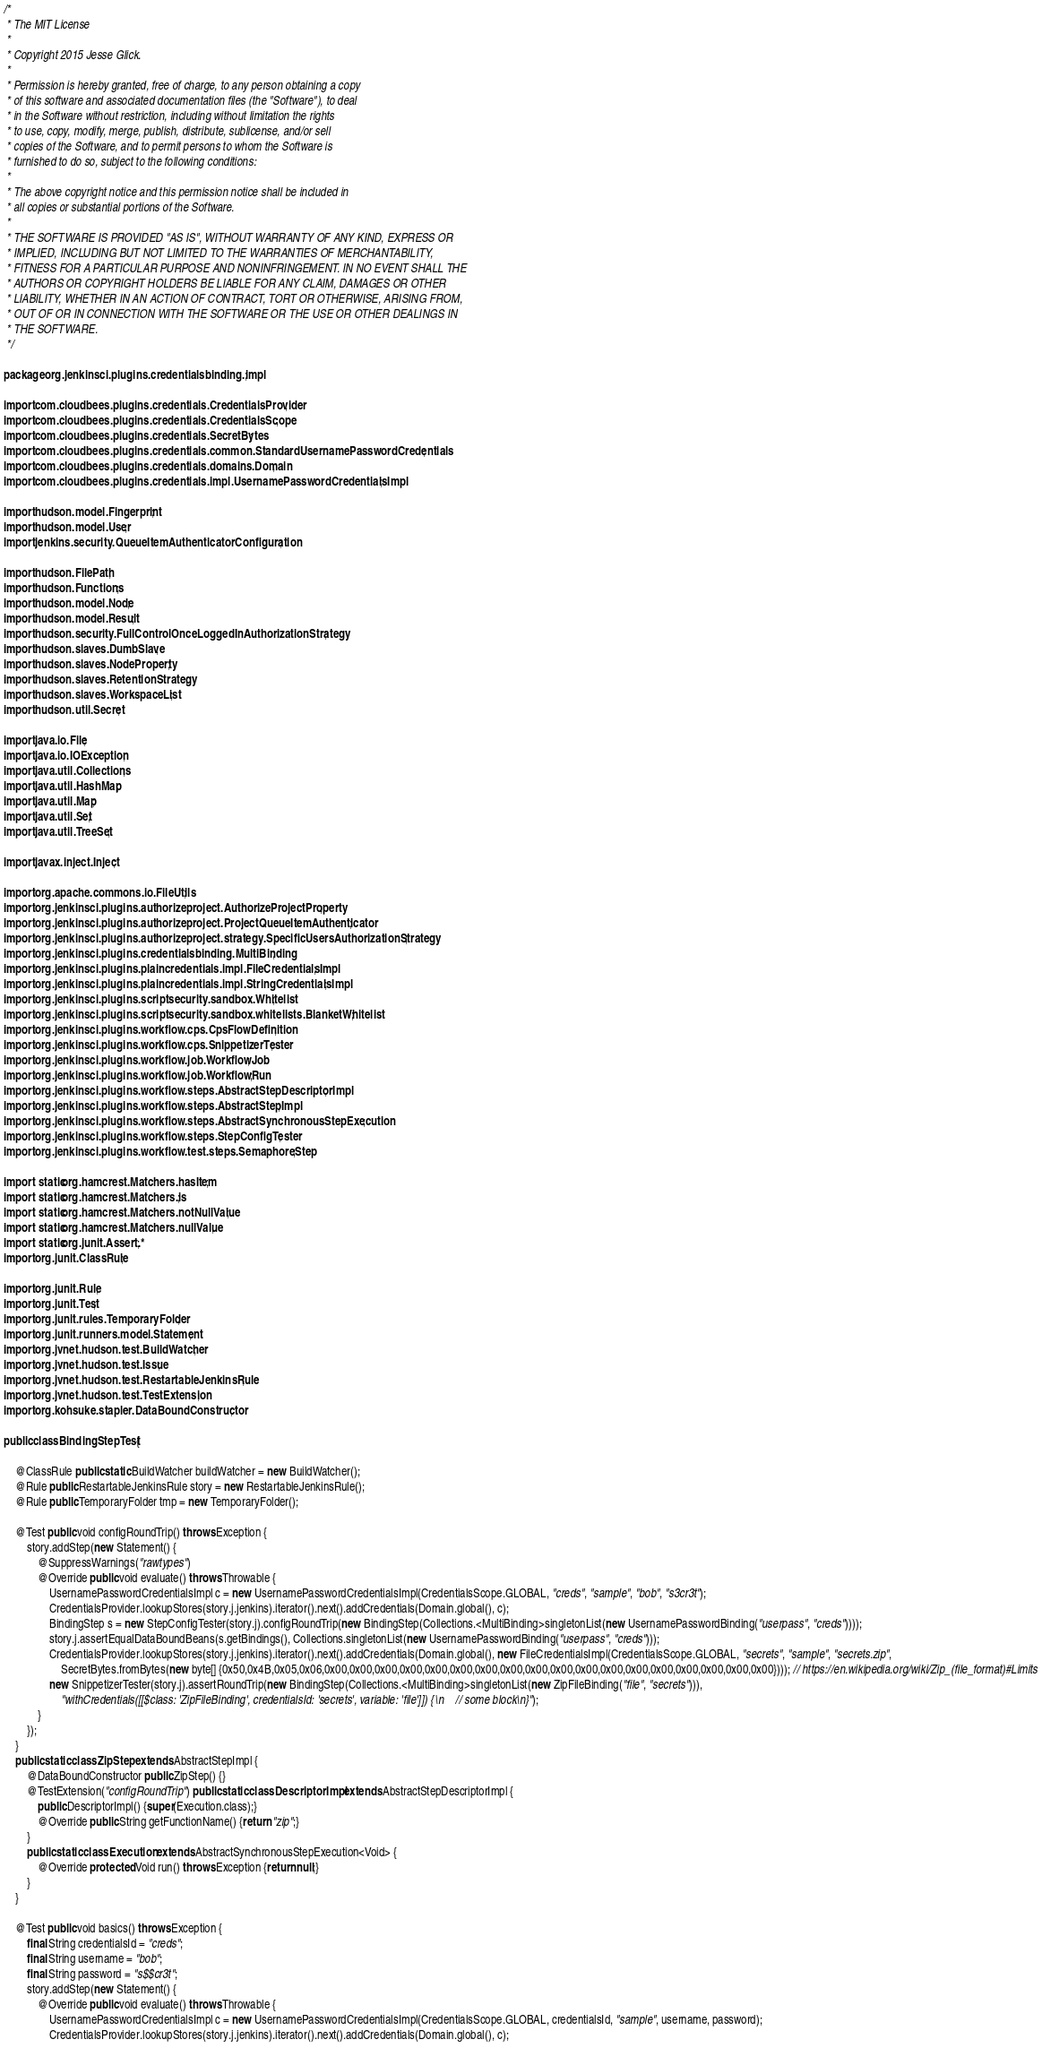Convert code to text. <code><loc_0><loc_0><loc_500><loc_500><_Java_>/*
 * The MIT License
 *
 * Copyright 2015 Jesse Glick.
 *
 * Permission is hereby granted, free of charge, to any person obtaining a copy
 * of this software and associated documentation files (the "Software"), to deal
 * in the Software without restriction, including without limitation the rights
 * to use, copy, modify, merge, publish, distribute, sublicense, and/or sell
 * copies of the Software, and to permit persons to whom the Software is
 * furnished to do so, subject to the following conditions:
 *
 * The above copyright notice and this permission notice shall be included in
 * all copies or substantial portions of the Software.
 *
 * THE SOFTWARE IS PROVIDED "AS IS", WITHOUT WARRANTY OF ANY KIND, EXPRESS OR
 * IMPLIED, INCLUDING BUT NOT LIMITED TO THE WARRANTIES OF MERCHANTABILITY,
 * FITNESS FOR A PARTICULAR PURPOSE AND NONINFRINGEMENT. IN NO EVENT SHALL THE
 * AUTHORS OR COPYRIGHT HOLDERS BE LIABLE FOR ANY CLAIM, DAMAGES OR OTHER
 * LIABILITY, WHETHER IN AN ACTION OF CONTRACT, TORT OR OTHERWISE, ARISING FROM,
 * OUT OF OR IN CONNECTION WITH THE SOFTWARE OR THE USE OR OTHER DEALINGS IN
 * THE SOFTWARE.
 */

package org.jenkinsci.plugins.credentialsbinding.impl;

import com.cloudbees.plugins.credentials.CredentialsProvider;
import com.cloudbees.plugins.credentials.CredentialsScope;
import com.cloudbees.plugins.credentials.SecretBytes;
import com.cloudbees.plugins.credentials.common.StandardUsernamePasswordCredentials;
import com.cloudbees.plugins.credentials.domains.Domain;
import com.cloudbees.plugins.credentials.impl.UsernamePasswordCredentialsImpl;

import hudson.model.Fingerprint;
import hudson.model.User;
import jenkins.security.QueueItemAuthenticatorConfiguration;

import hudson.FilePath;
import hudson.Functions;
import hudson.model.Node;
import hudson.model.Result;
import hudson.security.FullControlOnceLoggedInAuthorizationStrategy;
import hudson.slaves.DumbSlave;
import hudson.slaves.NodeProperty;
import hudson.slaves.RetentionStrategy;
import hudson.slaves.WorkspaceList;
import hudson.util.Secret;

import java.io.File;
import java.io.IOException;
import java.util.Collections;
import java.util.HashMap;
import java.util.Map;
import java.util.Set;
import java.util.TreeSet;

import javax.inject.Inject;

import org.apache.commons.io.FileUtils;
import org.jenkinsci.plugins.authorizeproject.AuthorizeProjectProperty;
import org.jenkinsci.plugins.authorizeproject.ProjectQueueItemAuthenticator;
import org.jenkinsci.plugins.authorizeproject.strategy.SpecificUsersAuthorizationStrategy;
import org.jenkinsci.plugins.credentialsbinding.MultiBinding;
import org.jenkinsci.plugins.plaincredentials.impl.FileCredentialsImpl;
import org.jenkinsci.plugins.plaincredentials.impl.StringCredentialsImpl;
import org.jenkinsci.plugins.scriptsecurity.sandbox.Whitelist;
import org.jenkinsci.plugins.scriptsecurity.sandbox.whitelists.BlanketWhitelist;
import org.jenkinsci.plugins.workflow.cps.CpsFlowDefinition;
import org.jenkinsci.plugins.workflow.cps.SnippetizerTester;
import org.jenkinsci.plugins.workflow.job.WorkflowJob;
import org.jenkinsci.plugins.workflow.job.WorkflowRun;
import org.jenkinsci.plugins.workflow.steps.AbstractStepDescriptorImpl;
import org.jenkinsci.plugins.workflow.steps.AbstractStepImpl;
import org.jenkinsci.plugins.workflow.steps.AbstractSynchronousStepExecution;
import org.jenkinsci.plugins.workflow.steps.StepConfigTester;
import org.jenkinsci.plugins.workflow.test.steps.SemaphoreStep;

import static org.hamcrest.Matchers.hasItem;
import static org.hamcrest.Matchers.is;
import static org.hamcrest.Matchers.notNullValue;
import static org.hamcrest.Matchers.nullValue;
import static org.junit.Assert.*;
import org.junit.ClassRule;

import org.junit.Rule;
import org.junit.Test;
import org.junit.rules.TemporaryFolder;
import org.junit.runners.model.Statement;
import org.jvnet.hudson.test.BuildWatcher;
import org.jvnet.hudson.test.Issue;
import org.jvnet.hudson.test.RestartableJenkinsRule;
import org.jvnet.hudson.test.TestExtension;
import org.kohsuke.stapler.DataBoundConstructor;

public class BindingStepTest {

    @ClassRule public static BuildWatcher buildWatcher = new BuildWatcher();
    @Rule public RestartableJenkinsRule story = new RestartableJenkinsRule();
    @Rule public TemporaryFolder tmp = new TemporaryFolder();

    @Test public void configRoundTrip() throws Exception {
        story.addStep(new Statement() {
            @SuppressWarnings("rawtypes")
            @Override public void evaluate() throws Throwable {
                UsernamePasswordCredentialsImpl c = new UsernamePasswordCredentialsImpl(CredentialsScope.GLOBAL, "creds", "sample", "bob", "s3cr3t");
                CredentialsProvider.lookupStores(story.j.jenkins).iterator().next().addCredentials(Domain.global(), c);
                BindingStep s = new StepConfigTester(story.j).configRoundTrip(new BindingStep(Collections.<MultiBinding>singletonList(new UsernamePasswordBinding("userpass", "creds"))));
                story.j.assertEqualDataBoundBeans(s.getBindings(), Collections.singletonList(new UsernamePasswordBinding("userpass", "creds")));
                CredentialsProvider.lookupStores(story.j.jenkins).iterator().next().addCredentials(Domain.global(), new FileCredentialsImpl(CredentialsScope.GLOBAL, "secrets", "sample", "secrets.zip",
                    SecretBytes.fromBytes(new byte[] {0x50,0x4B,0x05,0x06,0x00,0x00,0x00,0x00,0x00,0x00,0x00,0x00,0x00,0x00,0x00,0x00,0x00,0x00,0x00,0x00,0x00,0x00}))); // https://en.wikipedia.org/wiki/Zip_(file_format)#Limits
                new SnippetizerTester(story.j).assertRoundTrip(new BindingStep(Collections.<MultiBinding>singletonList(new ZipFileBinding("file", "secrets"))),
                    "withCredentials([[$class: 'ZipFileBinding', credentialsId: 'secrets', variable: 'file']]) {\n    // some block\n}");
            }
        });
    }
    public static class ZipStep extends AbstractStepImpl {
        @DataBoundConstructor public ZipStep() {}
        @TestExtension("configRoundTrip") public static class DescriptorImpl extends AbstractStepDescriptorImpl {
            public DescriptorImpl() {super(Execution.class);}
            @Override public String getFunctionName() {return "zip";}
        }
        public static class Execution extends AbstractSynchronousStepExecution<Void> {
            @Override protected Void run() throws Exception {return null;}
        }
    }

    @Test public void basics() throws Exception {
        final String credentialsId = "creds";
        final String username = "bob";
        final String password = "s$$cr3t";
        story.addStep(new Statement() {
            @Override public void evaluate() throws Throwable {
                UsernamePasswordCredentialsImpl c = new UsernamePasswordCredentialsImpl(CredentialsScope.GLOBAL, credentialsId, "sample", username, password);
                CredentialsProvider.lookupStores(story.j.jenkins).iterator().next().addCredentials(Domain.global(), c);</code> 